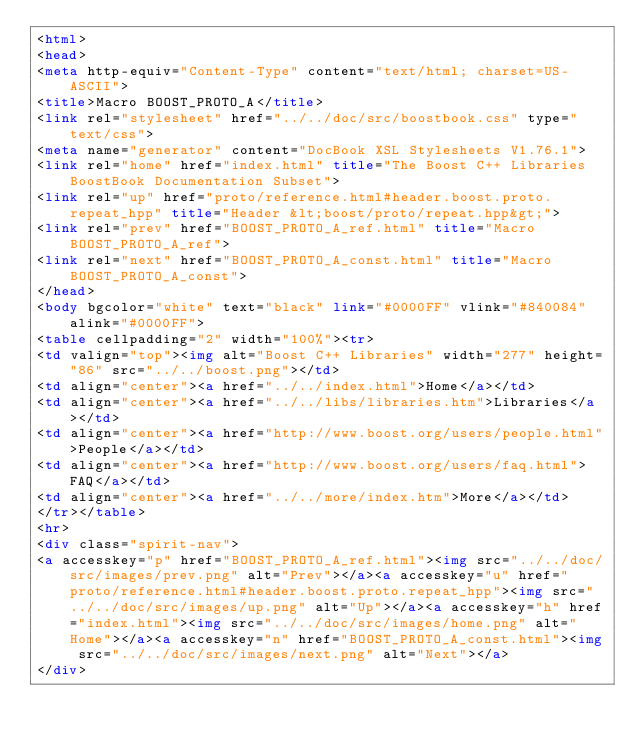Convert code to text. <code><loc_0><loc_0><loc_500><loc_500><_HTML_><html>
<head>
<meta http-equiv="Content-Type" content="text/html; charset=US-ASCII">
<title>Macro BOOST_PROTO_A</title>
<link rel="stylesheet" href="../../doc/src/boostbook.css" type="text/css">
<meta name="generator" content="DocBook XSL Stylesheets V1.76.1">
<link rel="home" href="index.html" title="The Boost C++ Libraries BoostBook Documentation Subset">
<link rel="up" href="proto/reference.html#header.boost.proto.repeat_hpp" title="Header &lt;boost/proto/repeat.hpp&gt;">
<link rel="prev" href="BOOST_PROTO_A_ref.html" title="Macro BOOST_PROTO_A_ref">
<link rel="next" href="BOOST_PROTO_A_const.html" title="Macro BOOST_PROTO_A_const">
</head>
<body bgcolor="white" text="black" link="#0000FF" vlink="#840084" alink="#0000FF">
<table cellpadding="2" width="100%"><tr>
<td valign="top"><img alt="Boost C++ Libraries" width="277" height="86" src="../../boost.png"></td>
<td align="center"><a href="../../index.html">Home</a></td>
<td align="center"><a href="../../libs/libraries.htm">Libraries</a></td>
<td align="center"><a href="http://www.boost.org/users/people.html">People</a></td>
<td align="center"><a href="http://www.boost.org/users/faq.html">FAQ</a></td>
<td align="center"><a href="../../more/index.htm">More</a></td>
</tr></table>
<hr>
<div class="spirit-nav">
<a accesskey="p" href="BOOST_PROTO_A_ref.html"><img src="../../doc/src/images/prev.png" alt="Prev"></a><a accesskey="u" href="proto/reference.html#header.boost.proto.repeat_hpp"><img src="../../doc/src/images/up.png" alt="Up"></a><a accesskey="h" href="index.html"><img src="../../doc/src/images/home.png" alt="Home"></a><a accesskey="n" href="BOOST_PROTO_A_const.html"><img src="../../doc/src/images/next.png" alt="Next"></a>
</div></code> 